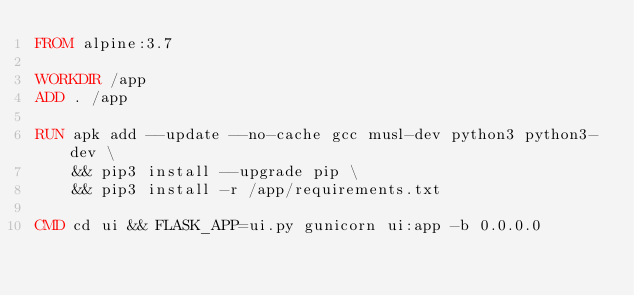Convert code to text. <code><loc_0><loc_0><loc_500><loc_500><_Dockerfile_>FROM alpine:3.7

WORKDIR /app
ADD . /app

RUN apk add --update --no-cache gcc musl-dev python3 python3-dev \
    && pip3 install --upgrade pip \
    && pip3 install -r /app/requirements.txt

CMD cd ui && FLASK_APP=ui.py gunicorn ui:app -b 0.0.0.0</code> 